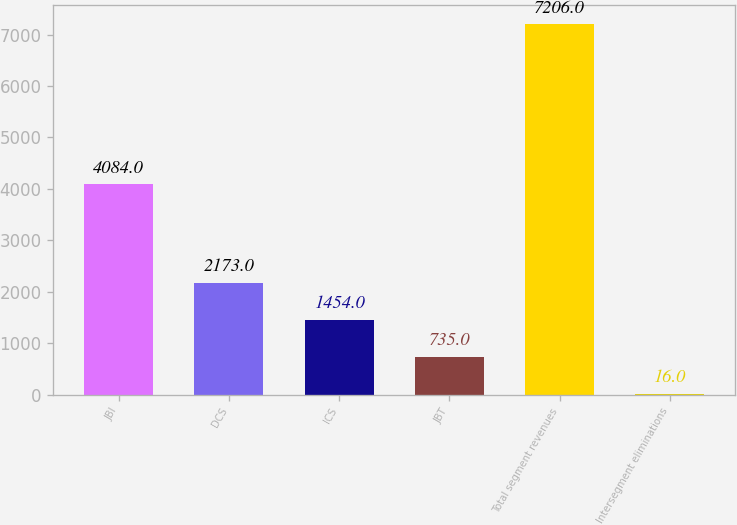<chart> <loc_0><loc_0><loc_500><loc_500><bar_chart><fcel>JBI<fcel>DCS<fcel>ICS<fcel>JBT<fcel>Total segment revenues<fcel>Intersegment eliminations<nl><fcel>4084<fcel>2173<fcel>1454<fcel>735<fcel>7206<fcel>16<nl></chart> 